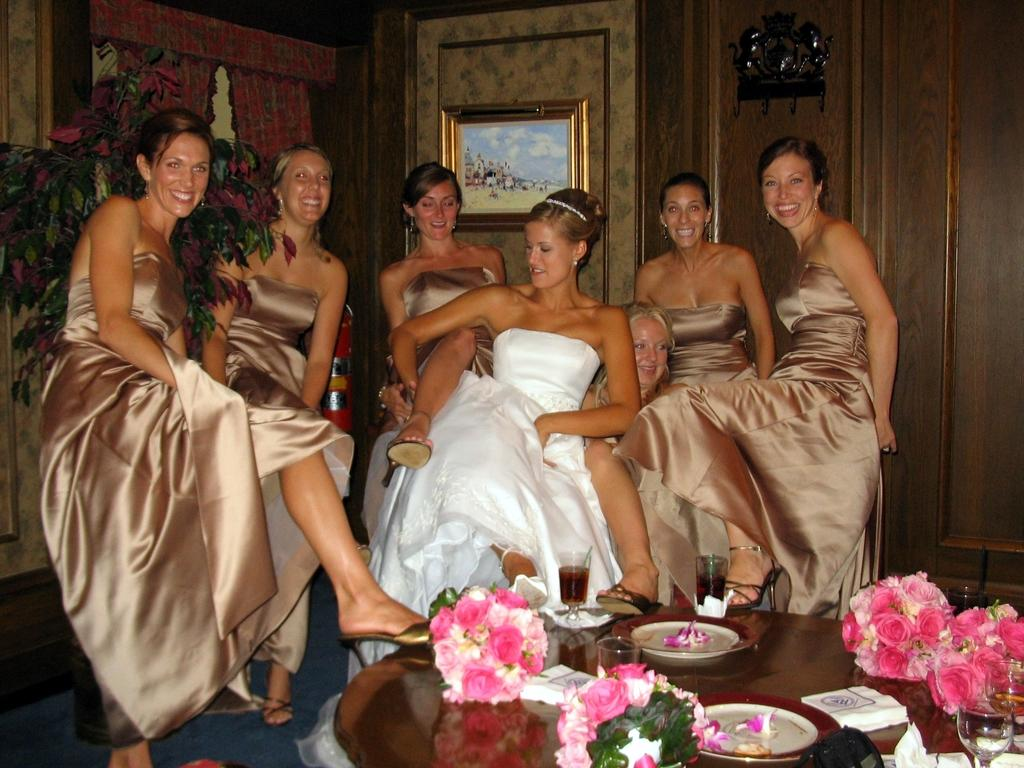What is the main subject of the image? There is a beautiful woman sitting in the middle of the image. What is the sitting woman wearing? The woman is wearing a white dress. Are there any other people in the image? Yes, there are other women standing near the sitting woman. What can be seen on the table in the image? There are flowers on a table in the image. What type of scent can be detected from the woman's dress in the image? There is no information about the scent of the woman's dress in the image. Is there a quiver present in the image? There is no quiver present in the image. 